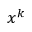<formula> <loc_0><loc_0><loc_500><loc_500>x ^ { k }</formula> 